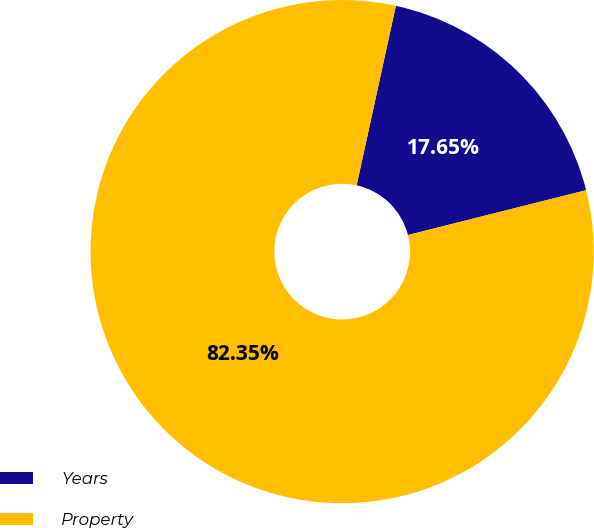Convert chart to OTSL. <chart><loc_0><loc_0><loc_500><loc_500><pie_chart><fcel>Years<fcel>Property<nl><fcel>17.65%<fcel>82.35%<nl></chart> 